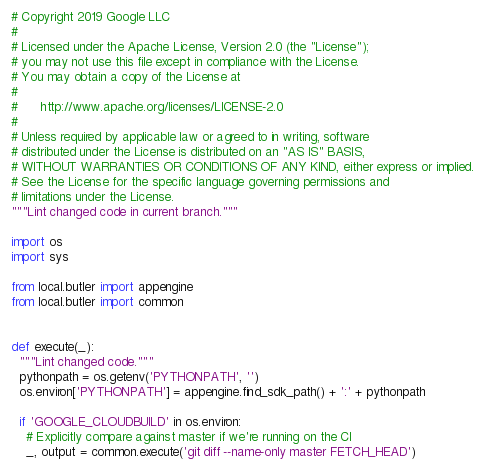<code> <loc_0><loc_0><loc_500><loc_500><_Python_># Copyright 2019 Google LLC
#
# Licensed under the Apache License, Version 2.0 (the "License");
# you may not use this file except in compliance with the License.
# You may obtain a copy of the License at
#
#      http://www.apache.org/licenses/LICENSE-2.0
#
# Unless required by applicable law or agreed to in writing, software
# distributed under the License is distributed on an "AS IS" BASIS,
# WITHOUT WARRANTIES OR CONDITIONS OF ANY KIND, either express or implied.
# See the License for the specific language governing permissions and
# limitations under the License.
"""Lint changed code in current branch."""

import os
import sys

from local.butler import appengine
from local.butler import common


def execute(_):
  """Lint changed code."""
  pythonpath = os.getenv('PYTHONPATH', '')
  os.environ['PYTHONPATH'] = appengine.find_sdk_path() + ':' + pythonpath

  if 'GOOGLE_CLOUDBUILD' in os.environ:
    # Explicitly compare against master if we're running on the CI
    _, output = common.execute('git diff --name-only master FETCH_HEAD')</code> 